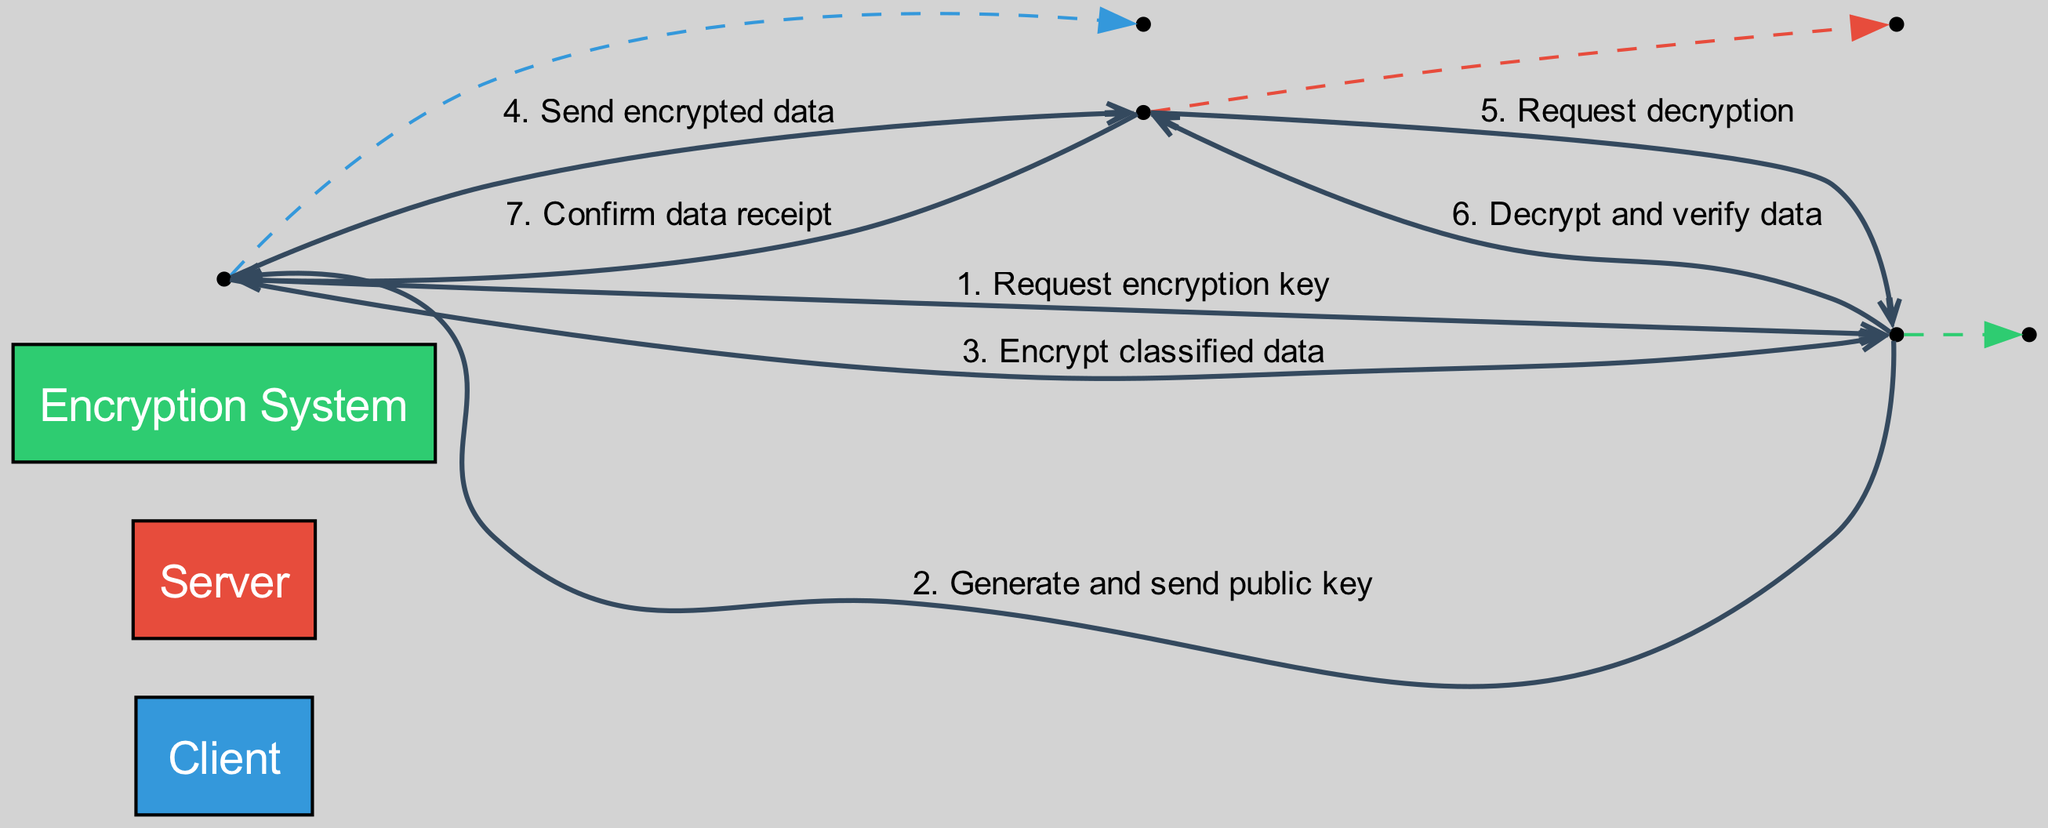What is the first message sent in the sequence? The first message sent is from the Client to the Encryption System, requesting the encryption key. This can be identified by looking at the messages listed in chronological order.
Answer: Request encryption key Who sends the encrypted data? The Client is the one who sends the encrypted data to the Server, as indicated in the fourth message in the sequence diagram.
Answer: Client How many actors are involved in the process? The diagram has three distinct actors: Client, Server, and Encryption System. This can be confirmed by counting the nodes representing actors in the diagram.
Answer: Three What is the last action taken in the diagram? The last action is "Confirm data receipt", which is sent by the Server to the Client, marking the end of the data transmission process in the sequence.
Answer: Confirm data receipt Which actor requests decryption? The actor that requests decryption is the Server, as shown in the fifth message exchanged in the diagram. This can be inferred by examining the messages flow where the Server communicates with the Encryption System.
Answer: Server What does the Encryption System send after the Client requests the encryption key? After receiving the request for the encryption key, the Encryption System sends the generated public key back to the Client, following the order of messages in the diagram.
Answer: Generate and send public key How many messages are exchanged between the actors? There are six messages exchanged in total as detailed in the messages list, which specifies each interaction.
Answer: Six Which message occurs after the Client encrypts classified data? The message that occurs after the Client encrypts classified data is "Send encrypted data" directed to the Server. This can be determined by following the sequence of actions after the encryption step.
Answer: Send encrypted data 